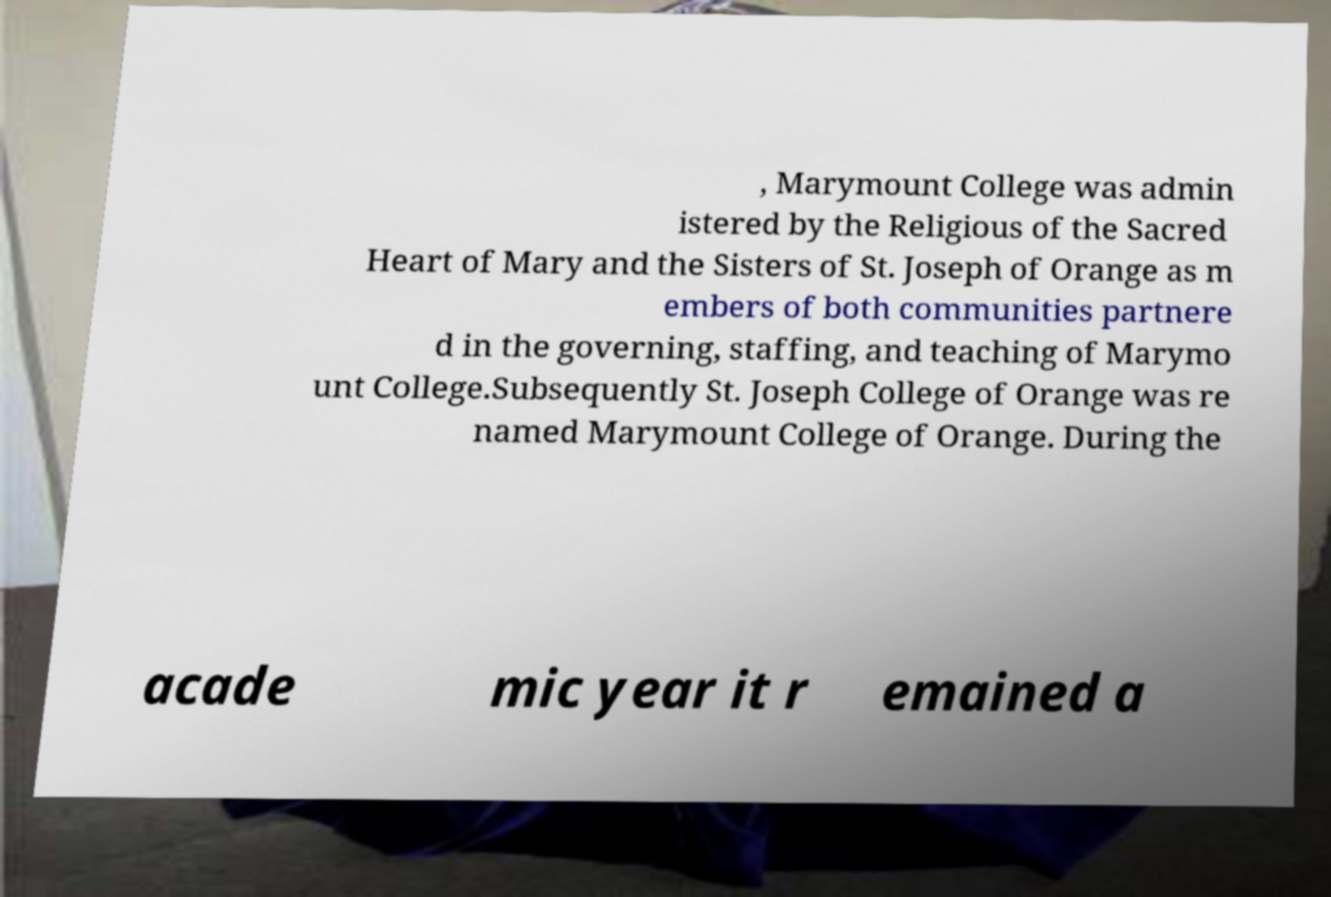Could you assist in decoding the text presented in this image and type it out clearly? , Marymount College was admin istered by the Religious of the Sacred Heart of Mary and the Sisters of St. Joseph of Orange as m embers of both communities partnere d in the governing, staffing, and teaching of Marymo unt College.Subsequently St. Joseph College of Orange was re named Marymount College of Orange. During the acade mic year it r emained a 